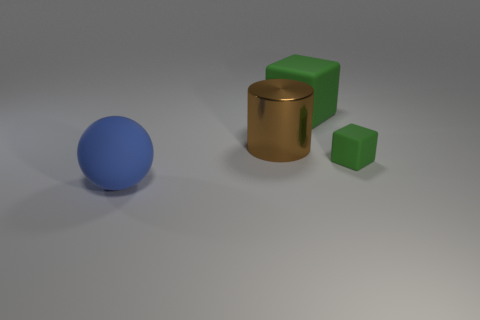How does the lighting in this image suggest depth? The lighting in the image creates soft shadows that stretch away from the objects, which helps to convey a sense of three-dimensional space and the relative positioning of the objects. The gradient of light to dark on the surface further emphasizes the contours and depth of the scene. 